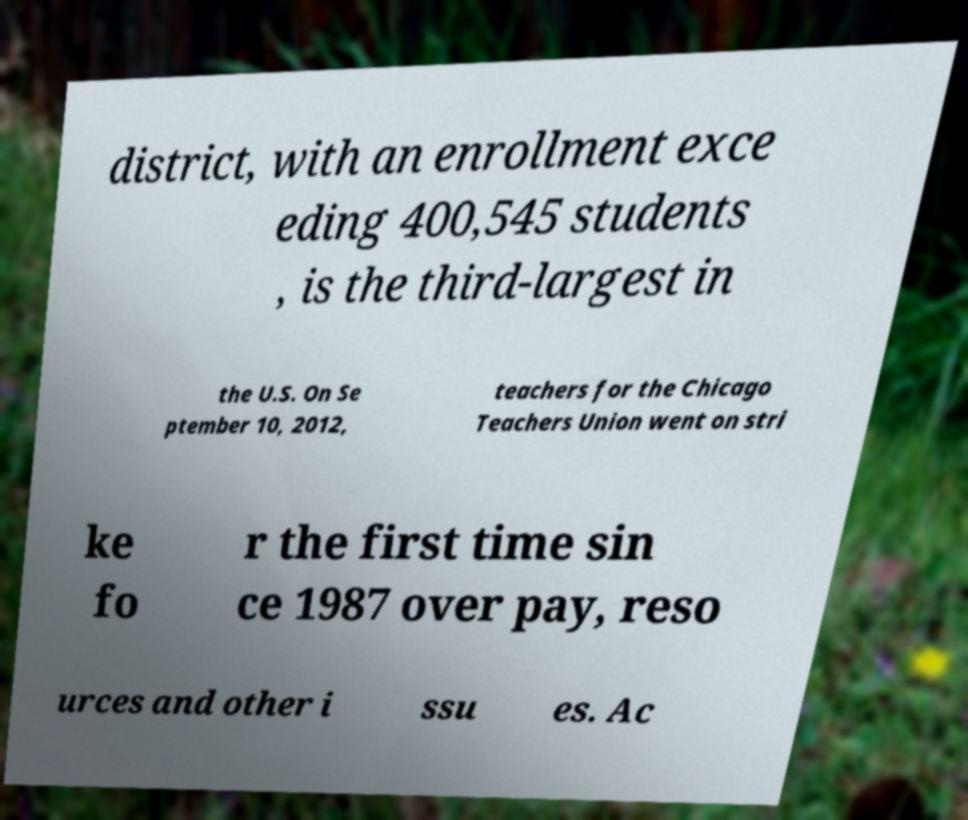Could you assist in decoding the text presented in this image and type it out clearly? district, with an enrollment exce eding 400,545 students , is the third-largest in the U.S. On Se ptember 10, 2012, teachers for the Chicago Teachers Union went on stri ke fo r the first time sin ce 1987 over pay, reso urces and other i ssu es. Ac 